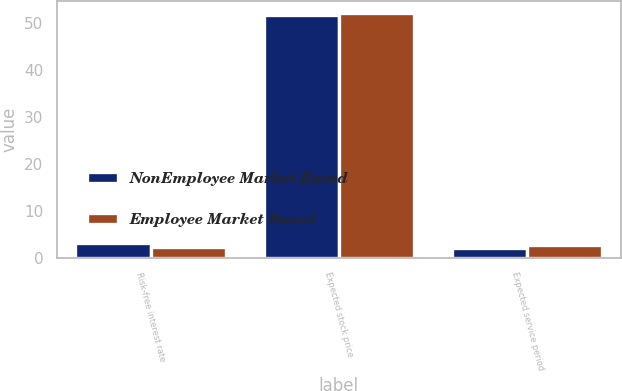<chart> <loc_0><loc_0><loc_500><loc_500><stacked_bar_chart><ecel><fcel>Risk-free interest rate<fcel>Expected stock price<fcel>Expected service period<nl><fcel>NonEmployee Market Based<fcel>3.1<fcel>51.8<fcel>2<nl><fcel>Employee Market Based<fcel>2.3<fcel>52.1<fcel>2.6<nl></chart> 